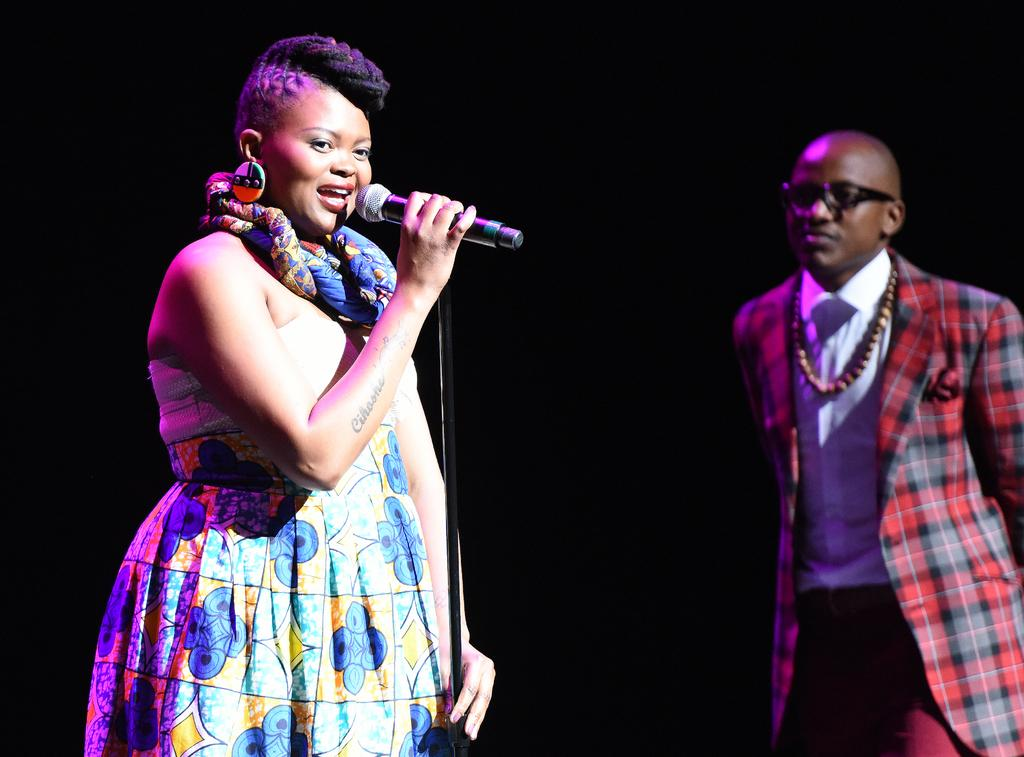What are the two people in the image doing? There is a man and a woman in the image, and the woman is holding a mic with a stand. Can you describe the woman's role in the image? The woman is holding a mic with a stand, which suggests she might be a speaker or performer. What is the man doing in the image? The facts provided do not specify what the man is doing in the image. What arithmetic problem is the man solving in the image? There is no arithmetic problem visible in the image, and the man's actions are not specified. 